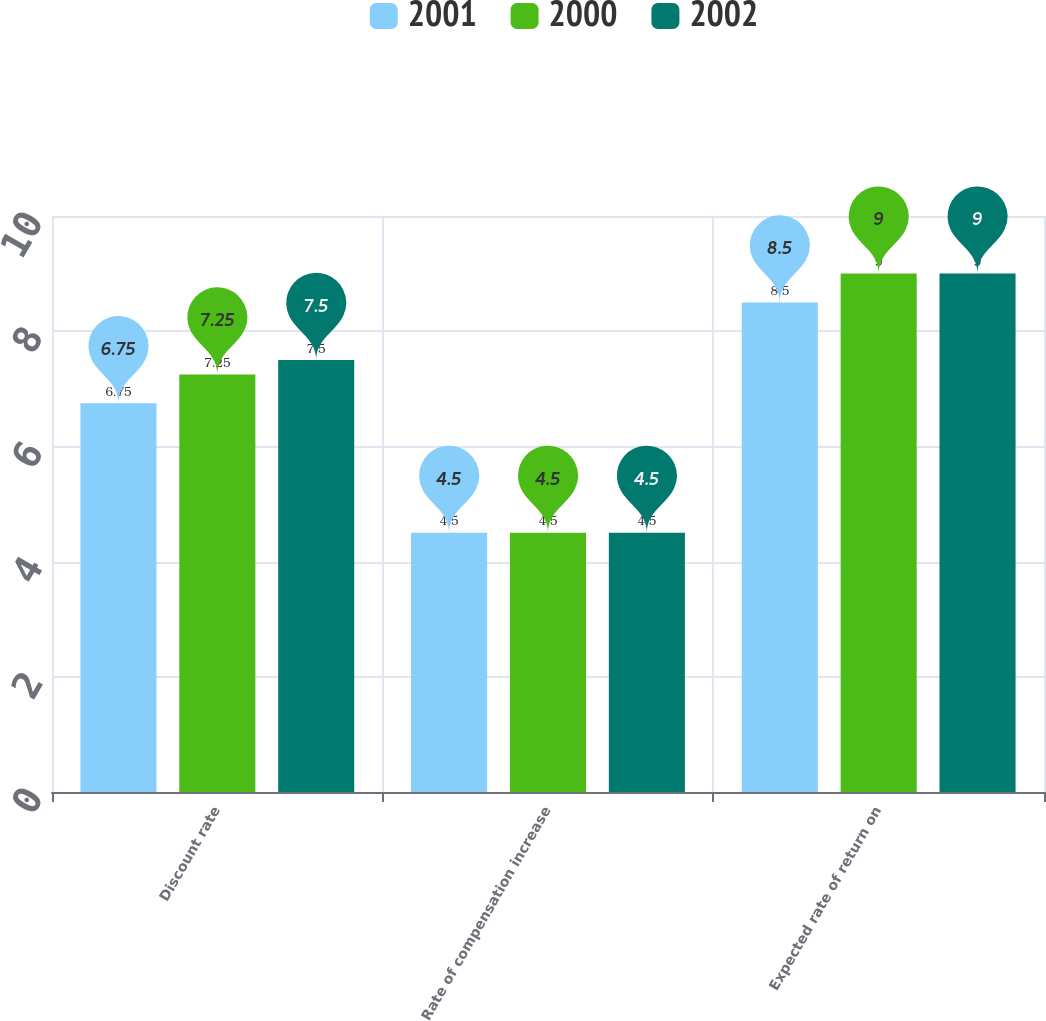Convert chart to OTSL. <chart><loc_0><loc_0><loc_500><loc_500><stacked_bar_chart><ecel><fcel>Discount rate<fcel>Rate of compensation increase<fcel>Expected rate of return on<nl><fcel>2001<fcel>6.75<fcel>4.5<fcel>8.5<nl><fcel>2000<fcel>7.25<fcel>4.5<fcel>9<nl><fcel>2002<fcel>7.5<fcel>4.5<fcel>9<nl></chart> 